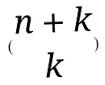<formula> <loc_0><loc_0><loc_500><loc_500>( \begin{matrix} n + k \\ k \end{matrix} )</formula> 